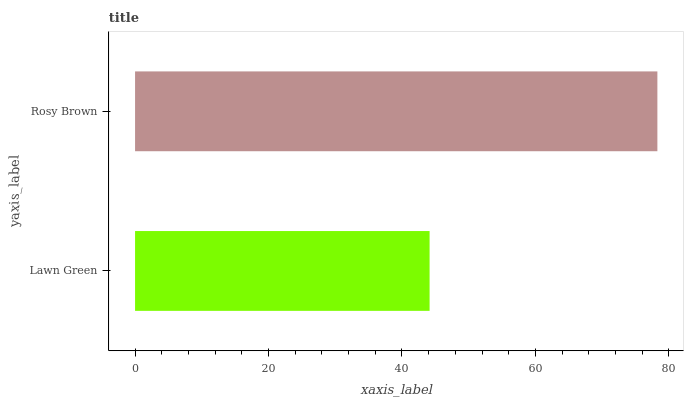Is Lawn Green the minimum?
Answer yes or no. Yes. Is Rosy Brown the maximum?
Answer yes or no. Yes. Is Rosy Brown the minimum?
Answer yes or no. No. Is Rosy Brown greater than Lawn Green?
Answer yes or no. Yes. Is Lawn Green less than Rosy Brown?
Answer yes or no. Yes. Is Lawn Green greater than Rosy Brown?
Answer yes or no. No. Is Rosy Brown less than Lawn Green?
Answer yes or no. No. Is Rosy Brown the high median?
Answer yes or no. Yes. Is Lawn Green the low median?
Answer yes or no. Yes. Is Lawn Green the high median?
Answer yes or no. No. Is Rosy Brown the low median?
Answer yes or no. No. 